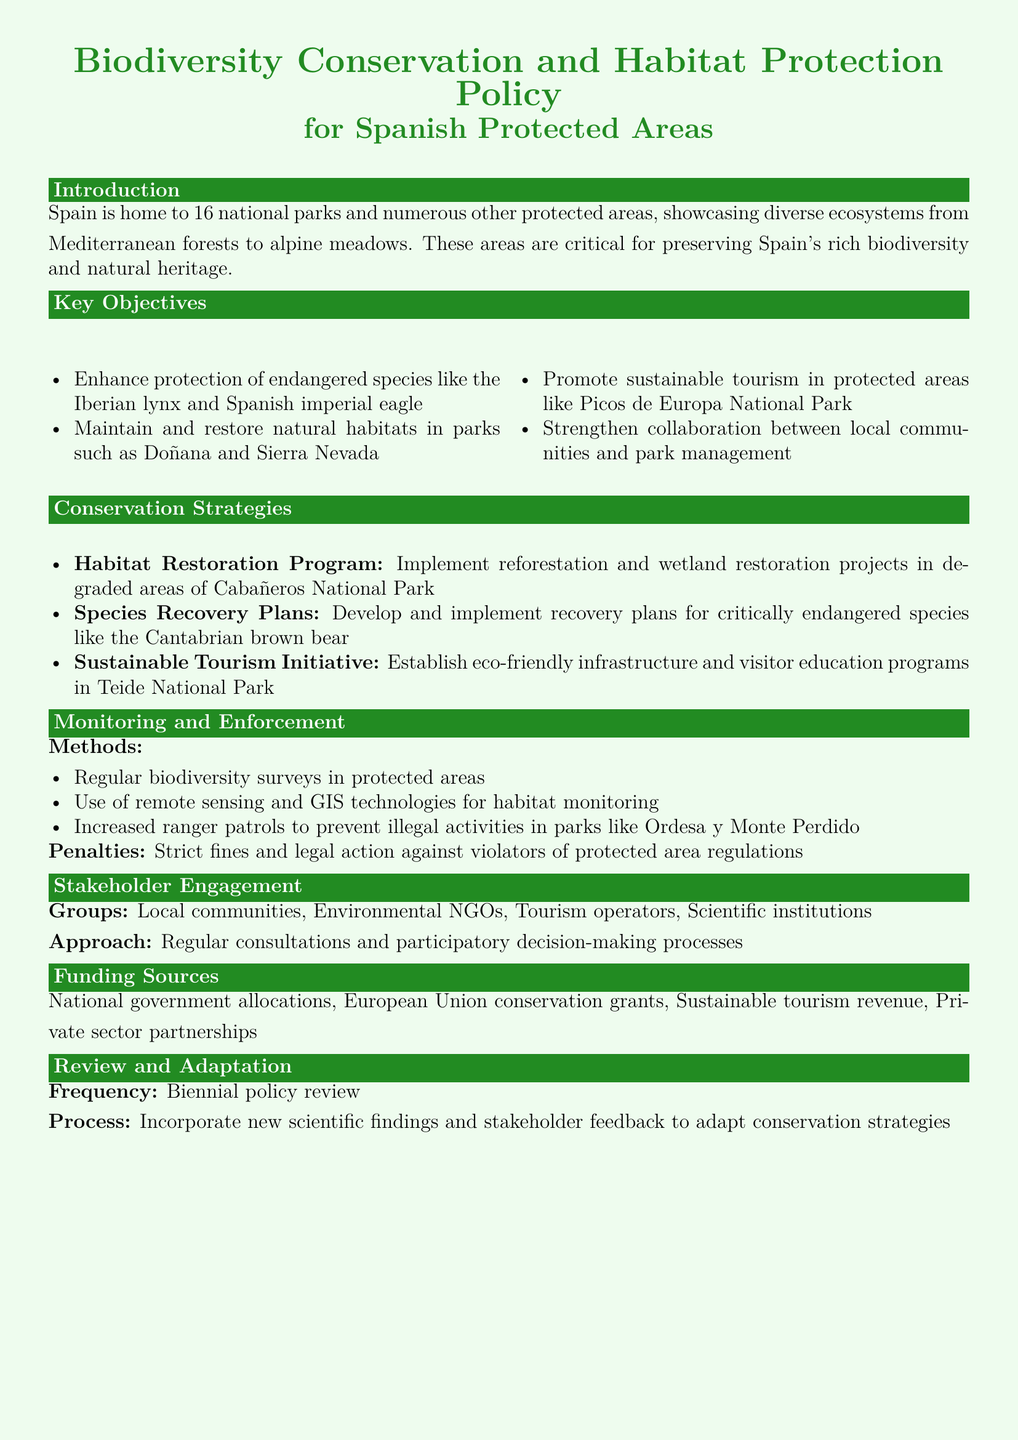What is the total number of national parks in Spain? The document states that Spain is home to 16 national parks.
Answer: 16 What endangered species are mentioned in the key objectives? The document specifically mentions the Iberian lynx and Spanish imperial eagle.
Answer: Iberian lynx and Spanish imperial eagle What is one of the main habitats targeted for restoration in Cabañeros National Park? The conservation strategies highlight reforestation and wetland restoration in degraded areas of this park.
Answer: Wetland How often will the policy be reviewed? It is stated that the policy review will be conducted biennially.
Answer: Biennial Which national park is associated with eco-friendly infrastructure and visitor education programs? The document mentions Teide National Park in the context of sustainable tourism initiatives.
Answer: Teide National Park What is the minimum method used for habitat monitoring mentioned in the document? The document refers to the use of remote sensing and GIS technologies for monitoring habitats.
Answer: Remote sensing and GIS technologies Who are the stakeholders involved in the engagement process? The document lists local communities, Environmental NGOs, tourism operators, and scientific institutions as stakeholders.
Answer: Local communities, Environmental NGOs, tourism operators, scientific institutions What type of penalties are described for violators of protected area regulations? The document notes that strict fines and legal action will be taken against violators.
Answer: Strict fines and legal action 